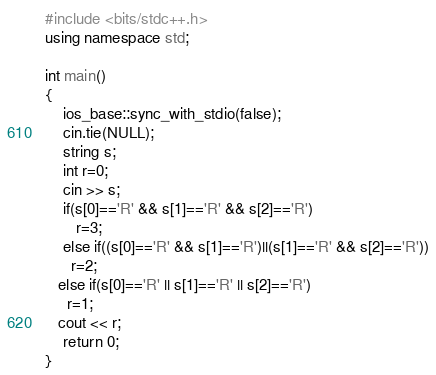<code> <loc_0><loc_0><loc_500><loc_500><_C++_>#include <bits/stdc++.h>
using namespace std;

int main()
{
    ios_base::sync_with_stdio(false);
    cin.tie(NULL);
    string s;
  	int r=0;
  	cin >> s;
    if(s[0]=='R' && s[1]=='R' && s[2]=='R')
       r=3;
    else if((s[0]=='R' && s[1]=='R')||(s[1]=='R' && s[2]=='R'))
      r=2;
   else if(s[0]=='R' || s[1]=='R' || s[2]=='R')
     r=1;
   cout << r;
    return 0;
}</code> 